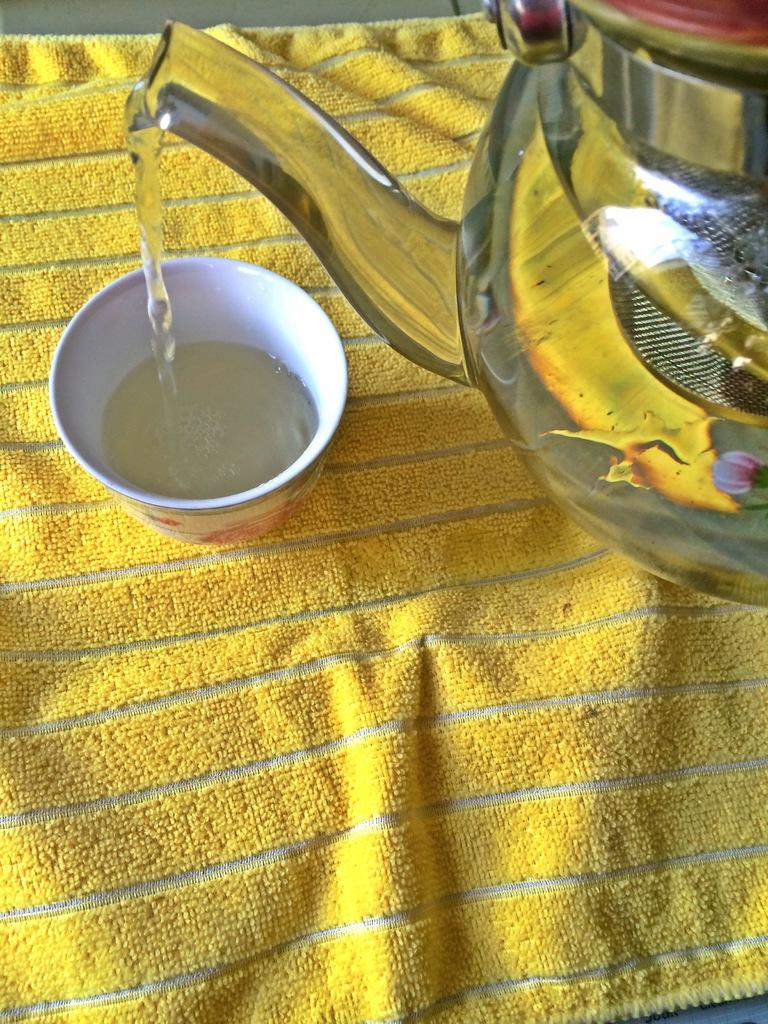What is the main object in the image? There is a kettle in the image. What is the kettle doing in the image? Liquid is pouring from the kettle. Where is the liquid being poured into? The liquid is pouring into a cup. What else can be seen in the image? There is a cloth present in the image. What type of books can be seen on the shelf in the image? There are no shelves or books present in the image; it only features a kettle, liquid pouring, a cup, and a cloth. 